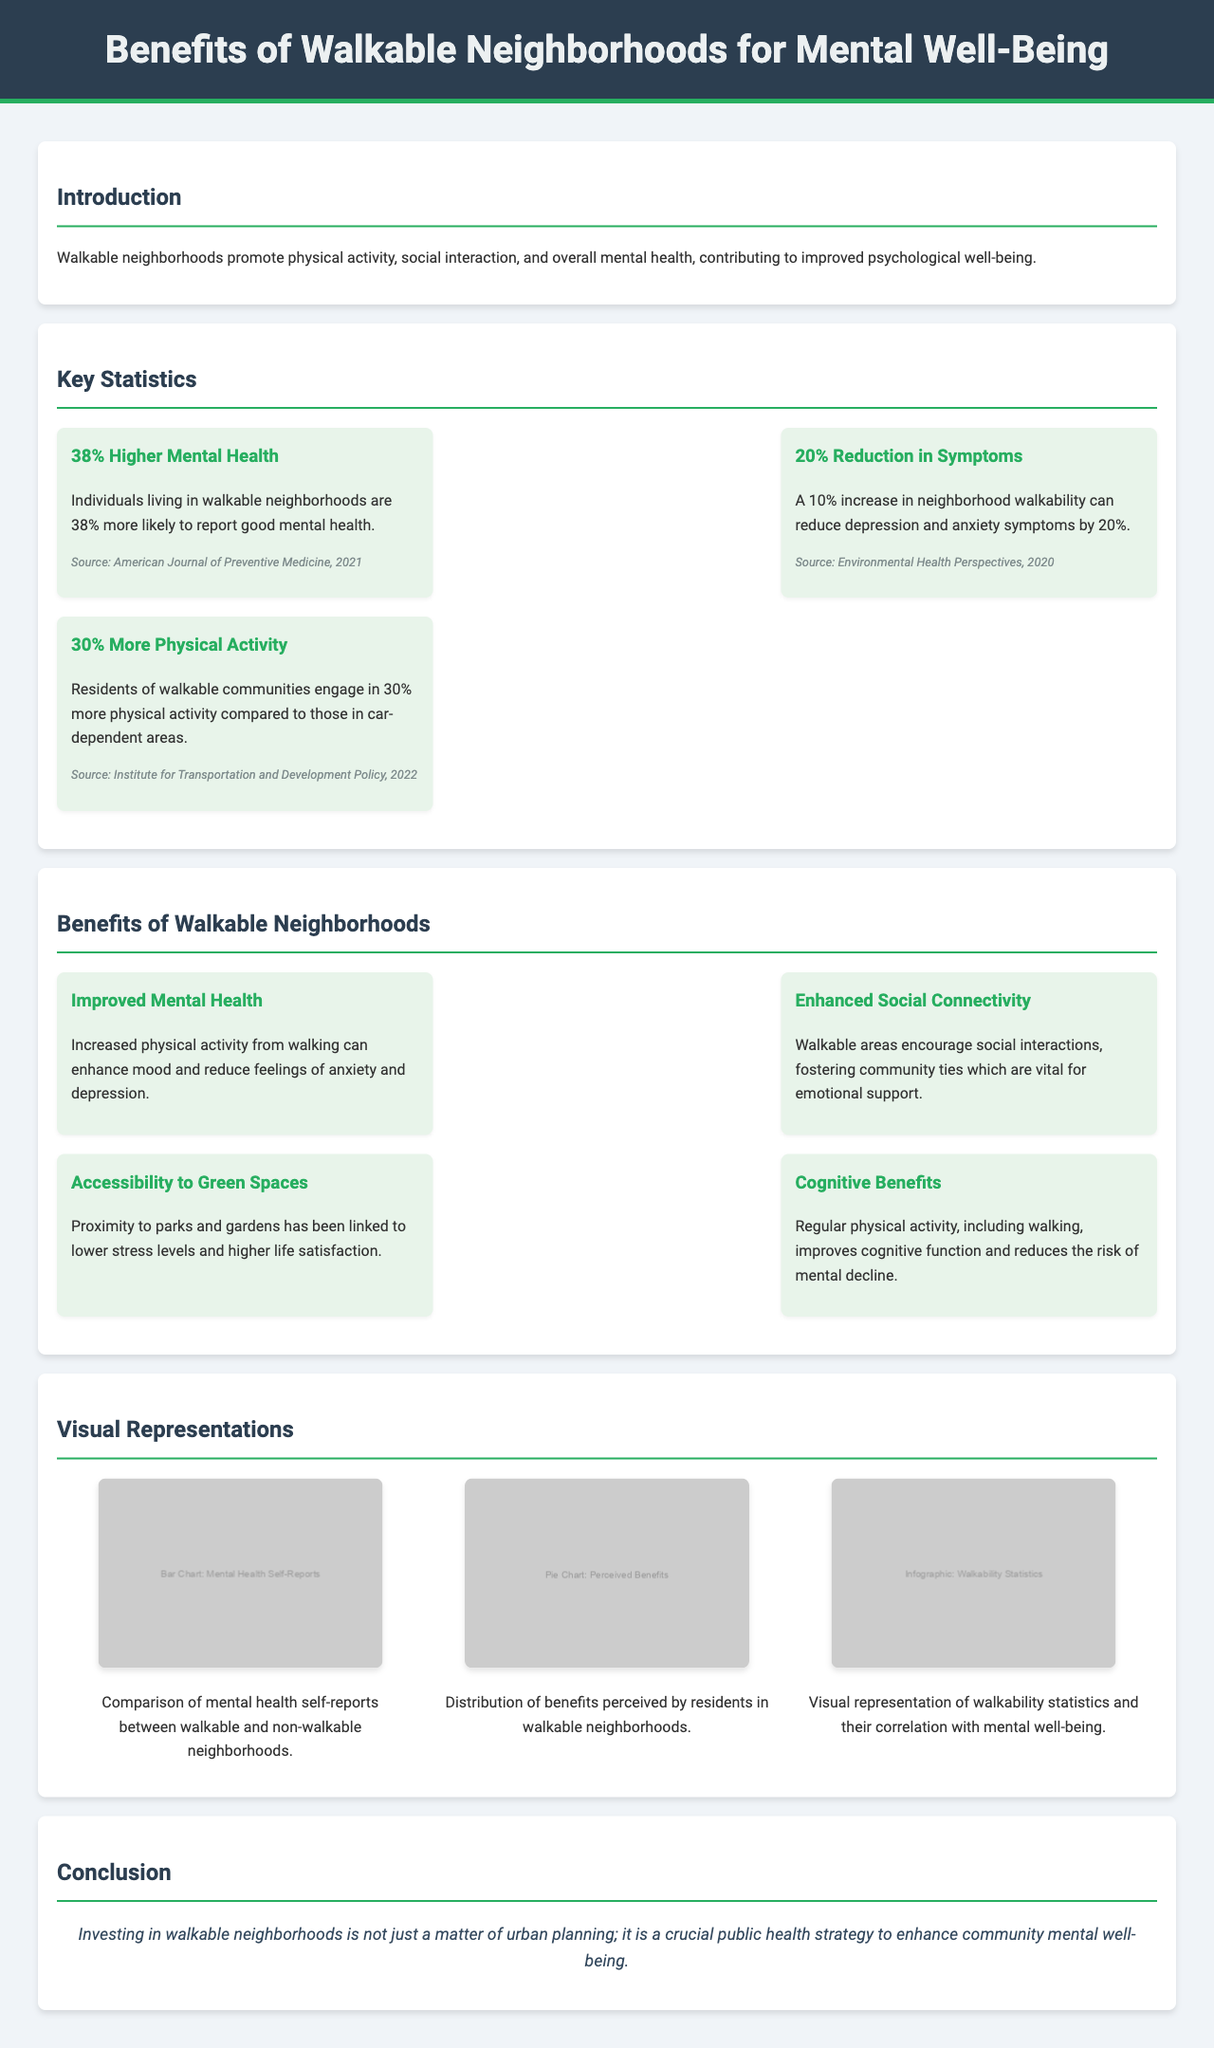What is the title of the document? The title is found in the header section of the document, which indicates the primary focus of the content.
Answer: Benefits of Walkable Neighborhoods for Mental Well-Being What percentage higher is mental health for individuals in walkable neighborhoods? This statistic is stated in the "Key Statistics" section, which provides specific data about mental health in relation to walkability.
Answer: 38% What is the documented reduction in anxiety and depression symptoms? This reduction is indicated in relation to the percentage increase in neighborhood walkability, providing insight into the psychological benefits of walkability.
Answer: 20% Which publication provides information about the 38% higher mental health statistic? The source of this statistic is specified at the end of the relevant data point in the statistics section.
Answer: American Journal of Preventive Medicine, 2021 What is one cognitive benefit mentioned in the document? The benefits section outlines various cognitive advantages associated with physical activity, specifically walking.
Answer: Cognitive function improvement How does living in walkable neighborhoods affect physical activity levels? This relates to the percentage increase in physical activity among residents of walkable areas, which is discussed in the statistics section.
Answer: 30% more What visual representation shows the comparison of mental health self-reports? The visual elements section describes multiple visual aids, particularly focusing on mental health comparisons between neighborhood types.
Answer: Bar Chart: Mental Health Self-Reports What is a key conclusion drawn from the document? The conclusion summarizes the overall message regarding public health strategies connected to urban planning, encapsulating the main points of the document.
Answer: Crucial public health strategy to enhance community mental well-being What type of neighborhoods promotes social interaction and emotional support? This aspect is discussed in the benefits section, highlighting the relationship between neighborhood design and social connectivity.
Answer: Walkable neighborhoods 